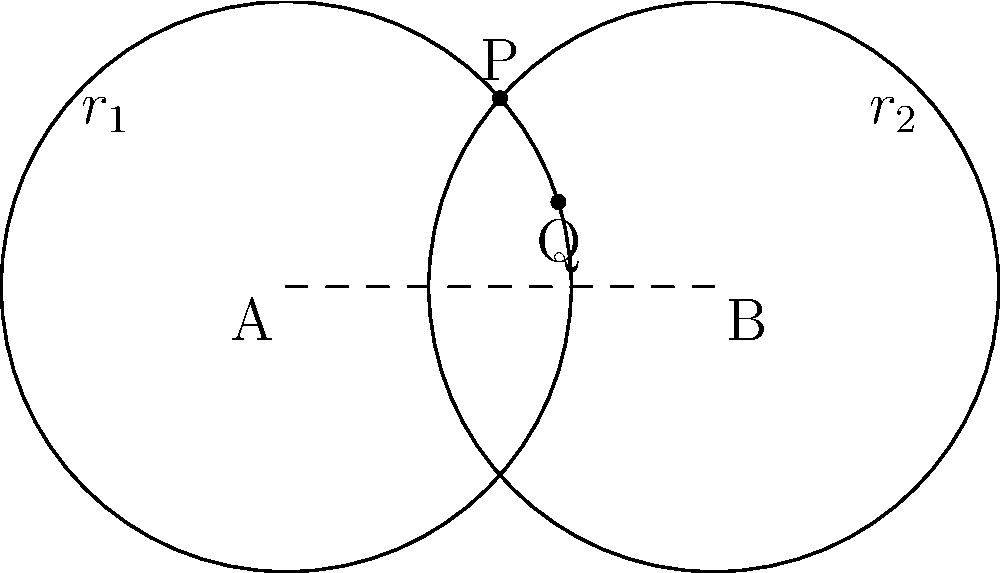In a garden of love, two circles of fragrant roses intertwine, creating a petal-like shape. Each circle has a radius of 2 units, and their centers are 3 units apart. How many intersection points do these floral circles have, symbolizing the connection between two hearts? Let's approach this step-by-step, drawing inspiration from the delicate balance of romance:

1) First, we need to determine if the circles intersect. For this, we compare the distance between the centers to the sum and difference of the radii:
   
   Distance between centers = 3
   Sum of radii = $r_1 + r_2 = 2 + 2 = 4$
   Difference of radii = $|r_1 - r_2| = |2 - 2| = 0$

2) For circles to intersect, the distance between centers must be:
   Less than the sum of radii: $3 < 4$ (True)
   Greater than the difference of radii: $3 > 0$ (True)

3) Since both conditions are met, the circles do intersect.

4) Now, we need to determine how many intersection points there are. Circles can intersect in either one point (if they are tangent) or two points.

5) For circles to be tangent, the distance between centers must equal either the sum or difference of radii. In this case:
   $3 \neq 4$ and $3 \neq 0$

6) Therefore, the circles are not tangent, which means they intersect at two points.

These two intersection points, like the meeting of two hearts in a romantic tale, symbolize the intertwining of our floral circles.
Answer: 2 intersection points 